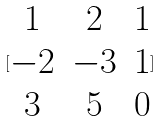Convert formula to latex. <formula><loc_0><loc_0><loc_500><loc_500>[ \begin{matrix} 1 & 2 & 1 \\ - 2 & - 3 & 1 \\ 3 & 5 & 0 \end{matrix} ]</formula> 